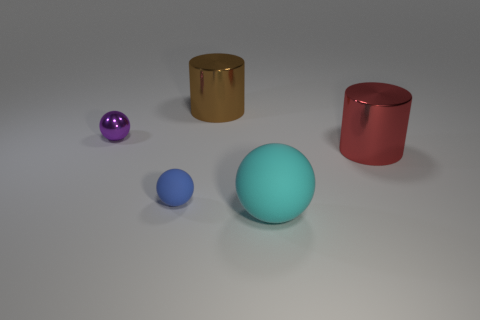Do the brown metallic thing and the big cyan rubber thing have the same shape?
Your answer should be compact. No. What number of objects are either large metal things that are behind the red thing or tiny gray rubber cylinders?
Your answer should be very brief. 1. Is there a purple metallic thing that has the same shape as the cyan rubber thing?
Provide a short and direct response. Yes. Are there an equal number of tiny metallic objects that are to the right of the tiny shiny object and tiny blue spheres?
Provide a succinct answer. No. How many matte balls have the same size as the purple metallic sphere?
Provide a short and direct response. 1. There is a red thing; how many big metallic cylinders are behind it?
Provide a succinct answer. 1. What material is the ball in front of the matte thing that is behind the large sphere made of?
Make the answer very short. Rubber. Are there any big metal spheres that have the same color as the tiny shiny object?
Your answer should be compact. No. There is another thing that is made of the same material as the large cyan object; what is its size?
Your answer should be very brief. Small. Is there any other thing that is the same color as the big sphere?
Your answer should be very brief. No. 